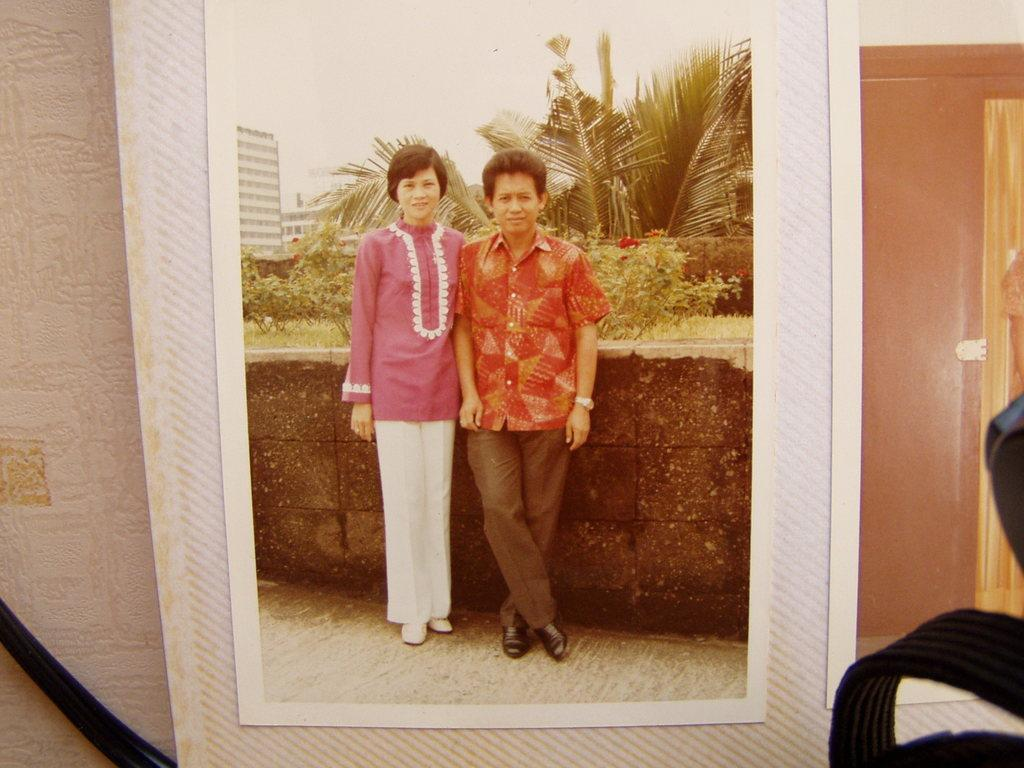What is the main subject of the image? The main subject of the image is a photo of a picture. What can be seen in the picture within the image? The picture contains plants and trees. How many people are in the picture? There are two persons in the picture. What are the persons wearing? The persons are wearing clothes. Where are the persons standing in the picture? The persons are standing in front of a wall. What type of cannon can be seen in the picture? There is no cannon present in the picture; it contains plants and trees, as well as two persons standing in front of a wall. Is there an orange tree visible in the picture? There is no mention of an orange tree or any specific type of tree in the provided facts, so it cannot be determined from the image. 